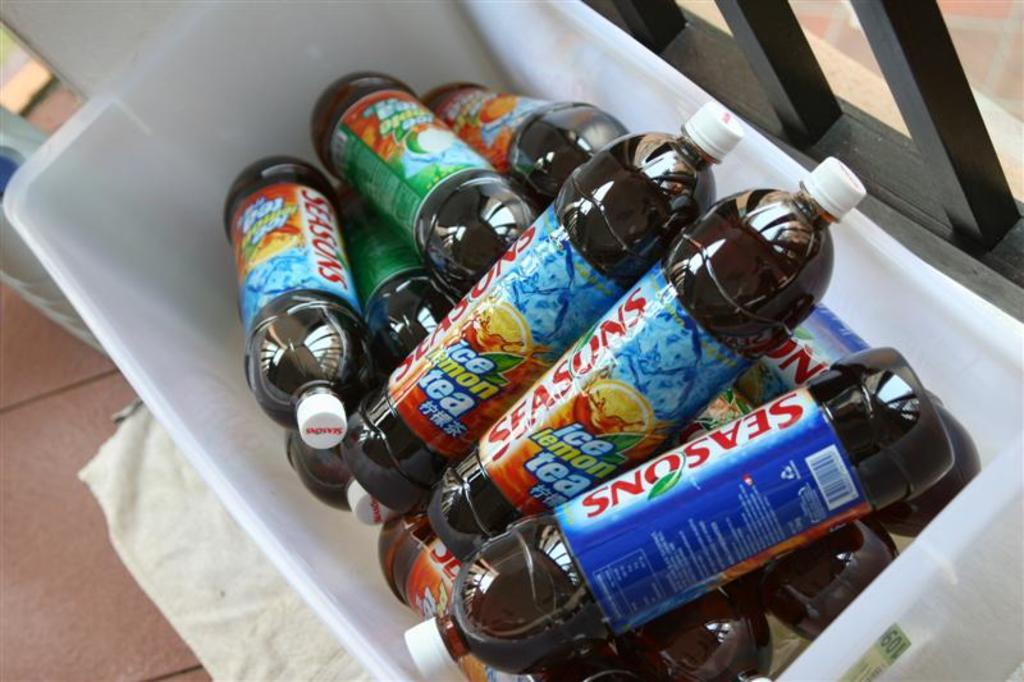<image>
Render a clear and concise summary of the photo. A number of bottles of soft drink called Seasons in a white plastic container. 